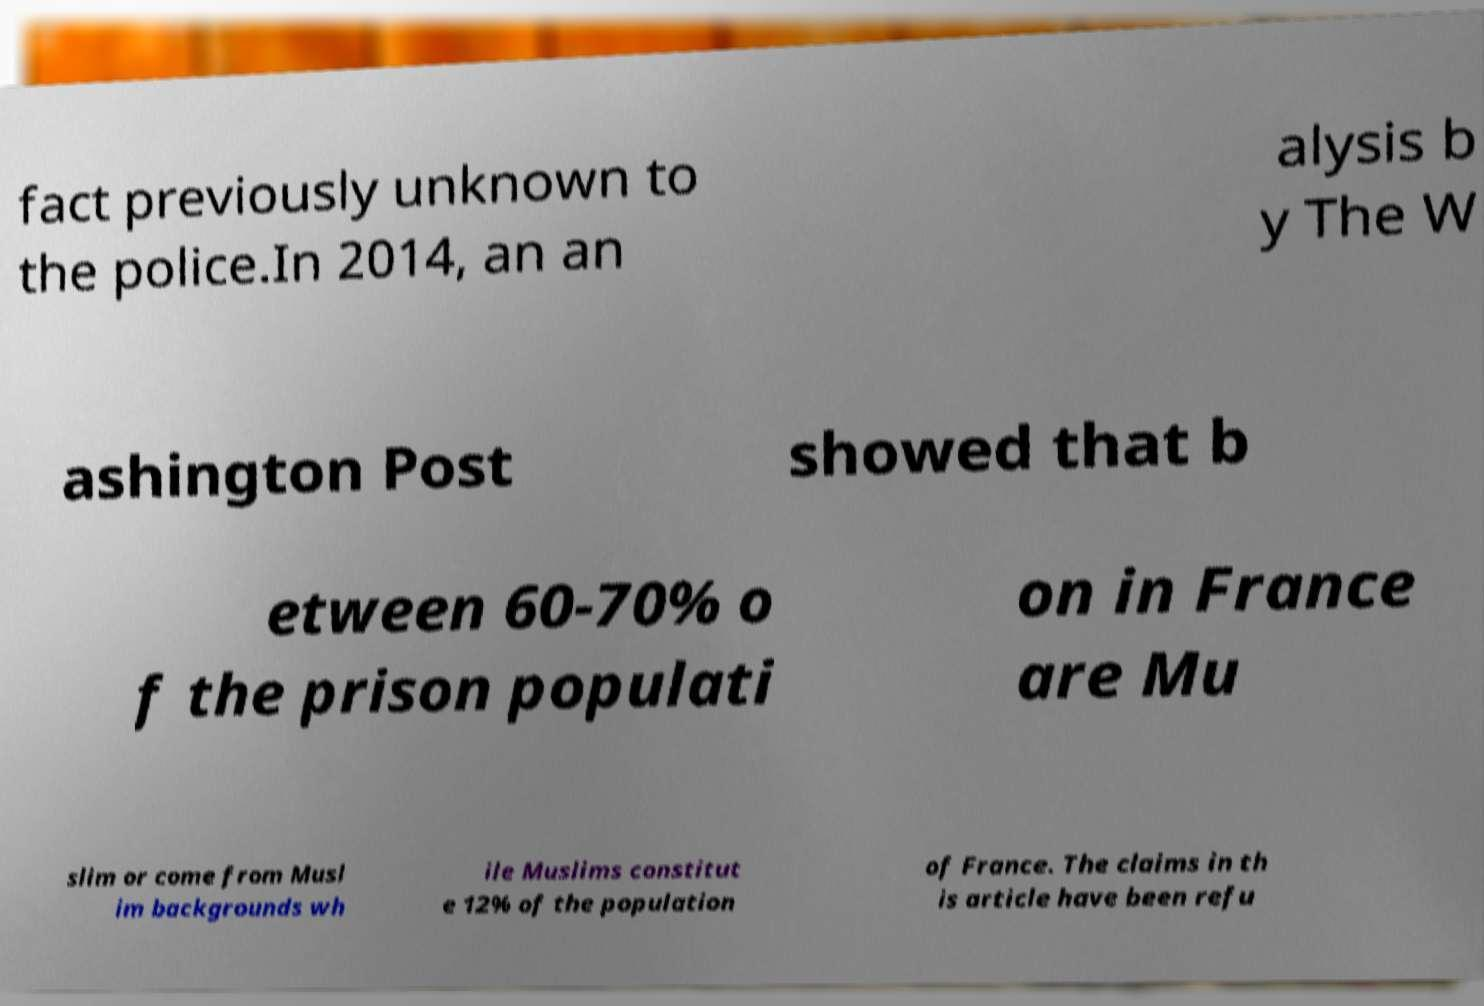Please identify and transcribe the text found in this image. fact previously unknown to the police.In 2014, an an alysis b y The W ashington Post showed that b etween 60-70% o f the prison populati on in France are Mu slim or come from Musl im backgrounds wh ile Muslims constitut e 12% of the population of France. The claims in th is article have been refu 